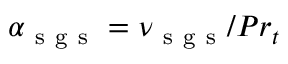Convert formula to latex. <formula><loc_0><loc_0><loc_500><loc_500>\alpha _ { s g s } = \nu _ { s g s } / P r _ { t }</formula> 